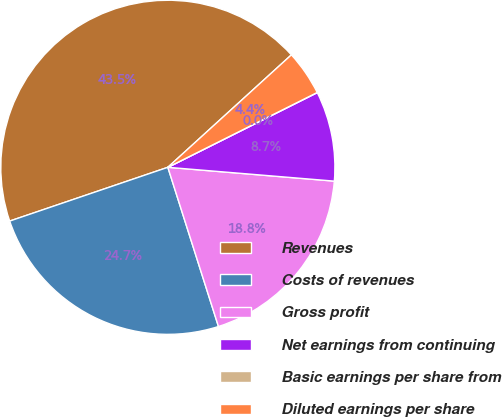<chart> <loc_0><loc_0><loc_500><loc_500><pie_chart><fcel>Revenues<fcel>Costs of revenues<fcel>Gross profit<fcel>Net earnings from continuing<fcel>Basic earnings per share from<fcel>Diluted earnings per share<nl><fcel>43.46%<fcel>24.68%<fcel>18.78%<fcel>8.7%<fcel>0.01%<fcel>4.36%<nl></chart> 